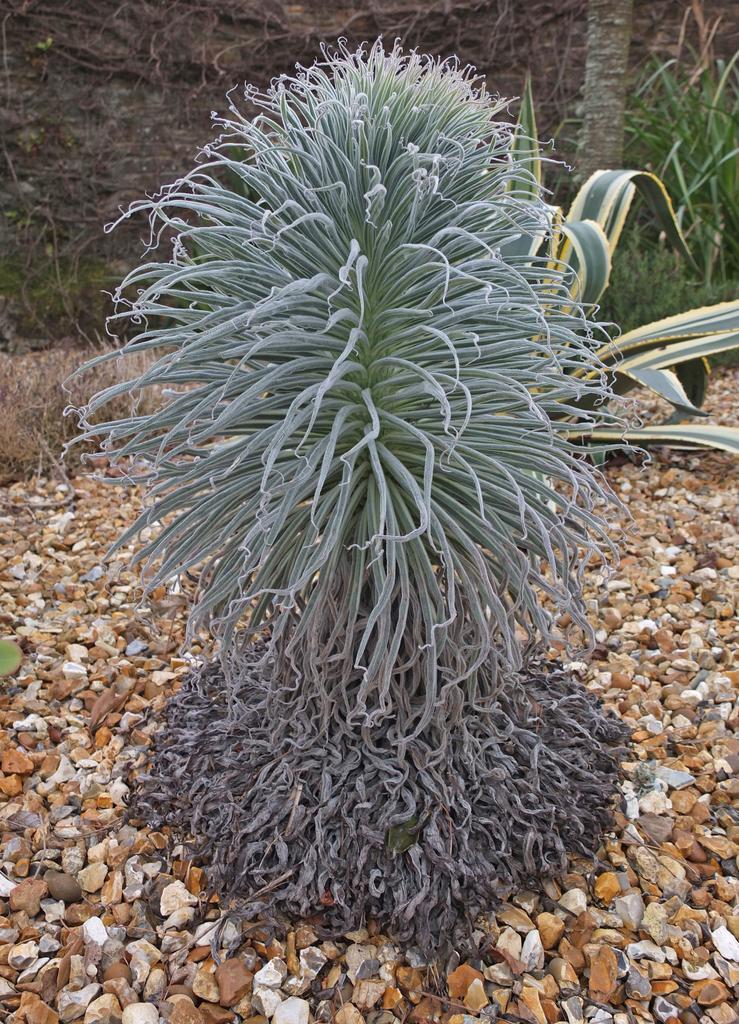Could you give a brief overview of what you see in this image? In this image I can see a plant in the front and around it I can see number of small stones. On the top right side of this image I can see few more plants and a tree trunk. 